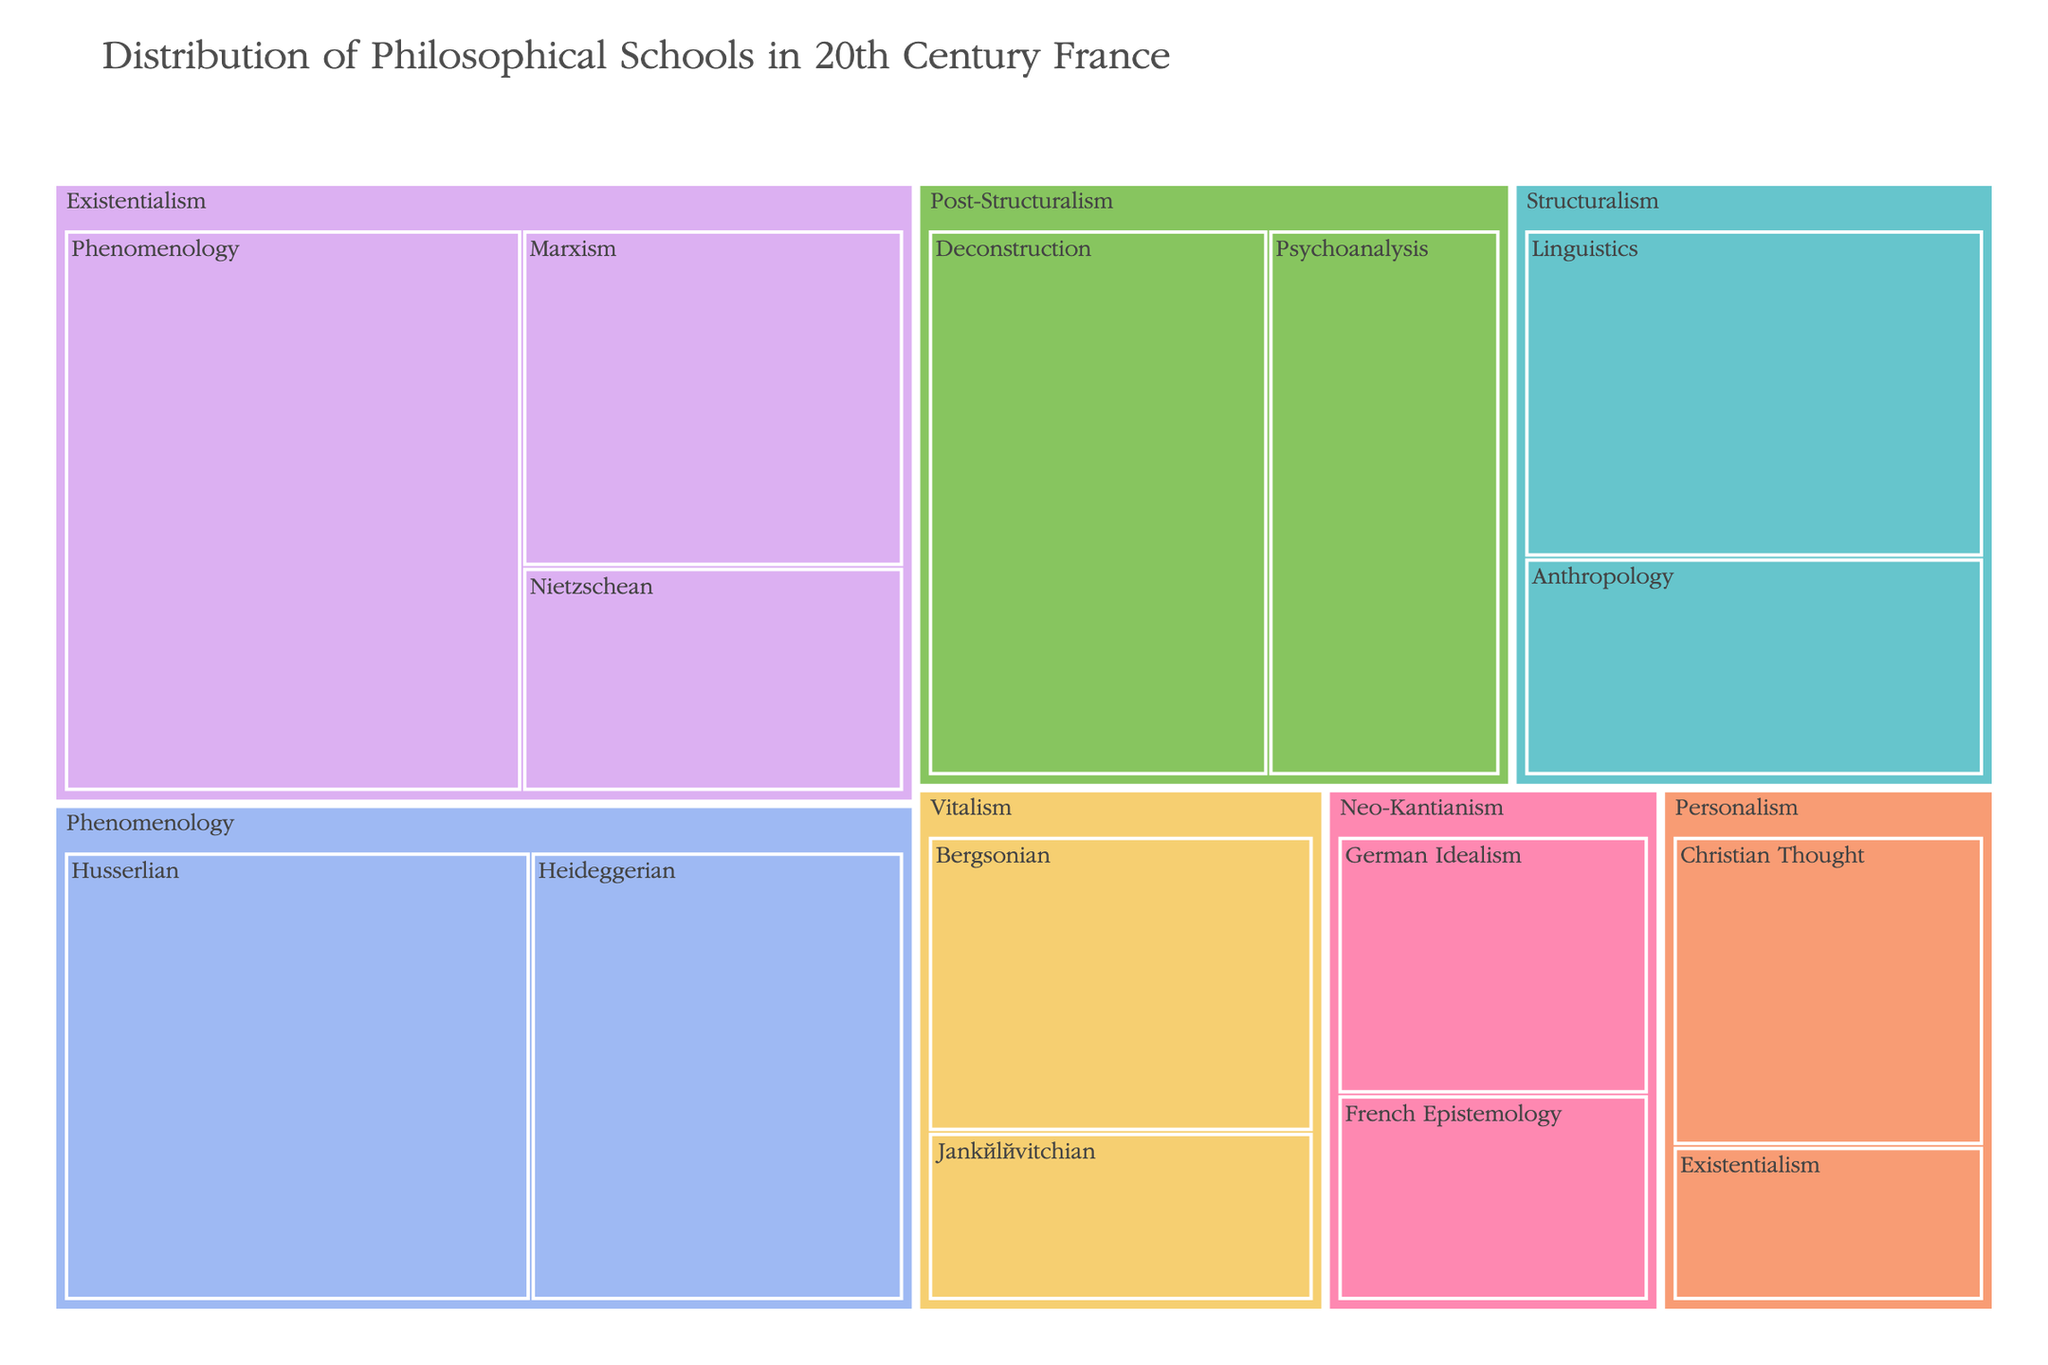What is the overarching title of the treemap? The title is at the top of the treemap and provides the primary context for the visualization: "Distribution of Philosophical Schools in 20th Century France".
Answer: Distribution of Philosophical Schools in 20th Century France Which school has the most philosophers influenced by Phenomenology? Phenomenology is a major category within the treemap, and it further breaks down into Husserlian and Heideggerian influences. By examining their values, Phenomenology has 25 Husserlian and 20 Heideggerian philosophers.
Answer: Phenomenology How many philosophers are influenced by Existentialism combined under Marxism and Nietzschean influences? Add the numbers from the treemap for Existentialism under Marxism and Nietzschean influences: 15 (Marxism) + 10 (Nietzschean) = 25.
Answer: 25 Compare the number of philosophers under Vitalism with those under Neo-Kantianism. Which one has more philosophers in total? Vitalism has 14 (Bergsonian) + 8 (Jankélévitchian) philosophers, totaling 22. Neo-Kantianism has 10 (German Idealism) + 8 (French Epistemology) philosophers, totaling 18. Thus, Vitalism has more philosophers in total.
Answer: Vitalism Which influence under Post-Structuralism has the most philosophers, and how many are there? Under Post-Structuralism, the numbers are displayed for Deconstruction and Psychoanalysis. Deconstruction has 22 philosophers, and Psychoanalysis has 15. Therefore, Deconstruction has the most.
Answer: Deconstruction, 22 What is the difference in the number of philosophers between Husserlian Phenomenology and German Idealism Neo-Kantianism? Husserlian Phenomenology has 25 philosophers and German Idealism Neo-Kantianism has 10. The difference is 25 - 10 = 15.
Answer: 15 How many philosophical schools have exactly two influences listed under them? By checking each category, Existentialism, Phenomenology, Structuralism, Post-Structuralism, Vitalism, Neo-Kantianism, and Personalism all have exactly two influences listed. Therefore, there are 7 such schools.
Answer: 7 Which school has the fewest philosophers in total, and how many do they have? Summing up the individual number of philosophers for each school, Personalism has the fewest philosophers: 12 (Christian Thought) + 6 (Existentialism) = 18.
Answer: Personalism, 18 